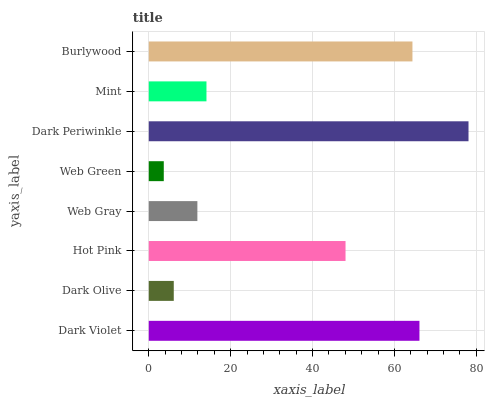Is Web Green the minimum?
Answer yes or no. Yes. Is Dark Periwinkle the maximum?
Answer yes or no. Yes. Is Dark Olive the minimum?
Answer yes or no. No. Is Dark Olive the maximum?
Answer yes or no. No. Is Dark Violet greater than Dark Olive?
Answer yes or no. Yes. Is Dark Olive less than Dark Violet?
Answer yes or no. Yes. Is Dark Olive greater than Dark Violet?
Answer yes or no. No. Is Dark Violet less than Dark Olive?
Answer yes or no. No. Is Hot Pink the high median?
Answer yes or no. Yes. Is Mint the low median?
Answer yes or no. Yes. Is Dark Olive the high median?
Answer yes or no. No. Is Hot Pink the low median?
Answer yes or no. No. 